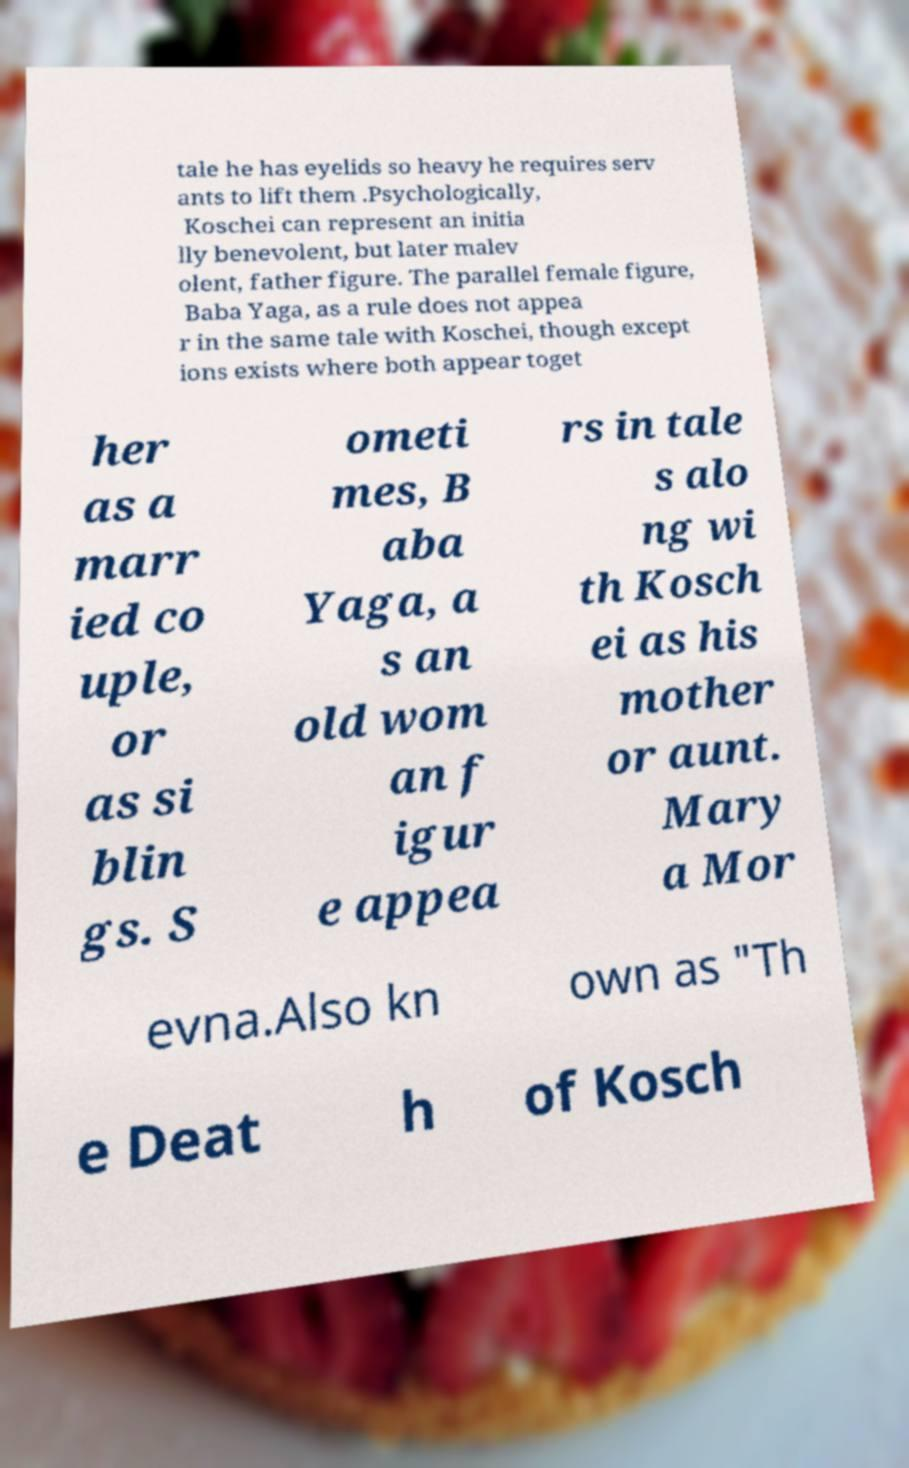There's text embedded in this image that I need extracted. Can you transcribe it verbatim? tale he has eyelids so heavy he requires serv ants to lift them .Psychologically, Koschei can represent an initia lly benevolent, but later malev olent, father figure. The parallel female figure, Baba Yaga, as a rule does not appea r in the same tale with Koschei, though except ions exists where both appear toget her as a marr ied co uple, or as si blin gs. S ometi mes, B aba Yaga, a s an old wom an f igur e appea rs in tale s alo ng wi th Kosch ei as his mother or aunt. Mary a Mor evna.Also kn own as "Th e Deat h of Kosch 